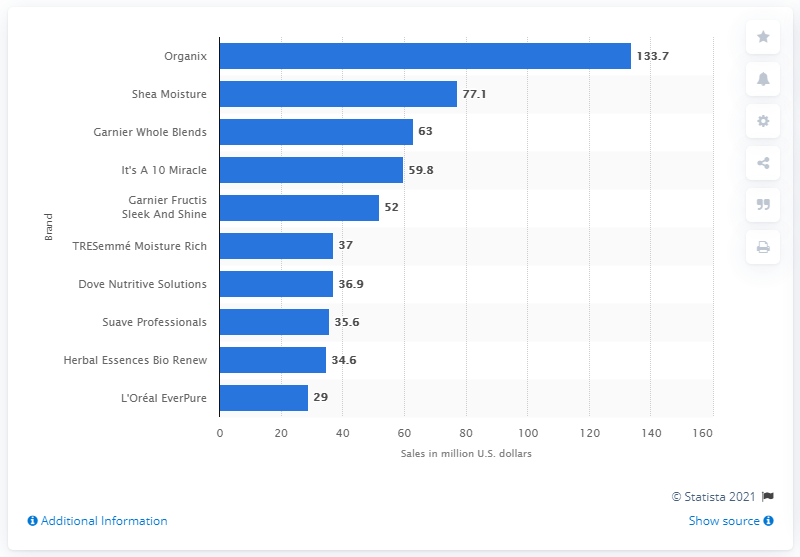Specify some key components in this picture. OGX had sales of 133.7 million dollars in the United States in 2018. 